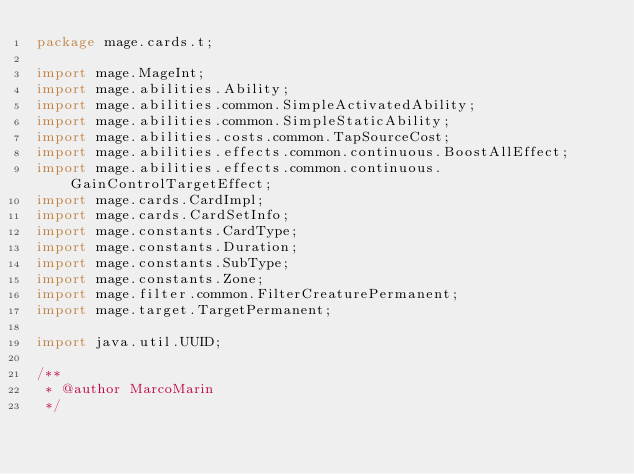<code> <loc_0><loc_0><loc_500><loc_500><_Java_>package mage.cards.t;

import mage.MageInt;
import mage.abilities.Ability;
import mage.abilities.common.SimpleActivatedAbility;
import mage.abilities.common.SimpleStaticAbility;
import mage.abilities.costs.common.TapSourceCost;
import mage.abilities.effects.common.continuous.BoostAllEffect;
import mage.abilities.effects.common.continuous.GainControlTargetEffect;
import mage.cards.CardImpl;
import mage.cards.CardSetInfo;
import mage.constants.CardType;
import mage.constants.Duration;
import mage.constants.SubType;
import mage.constants.Zone;
import mage.filter.common.FilterCreaturePermanent;
import mage.target.TargetPermanent;

import java.util.UUID;

/**
 * @author MarcoMarin
 */</code> 